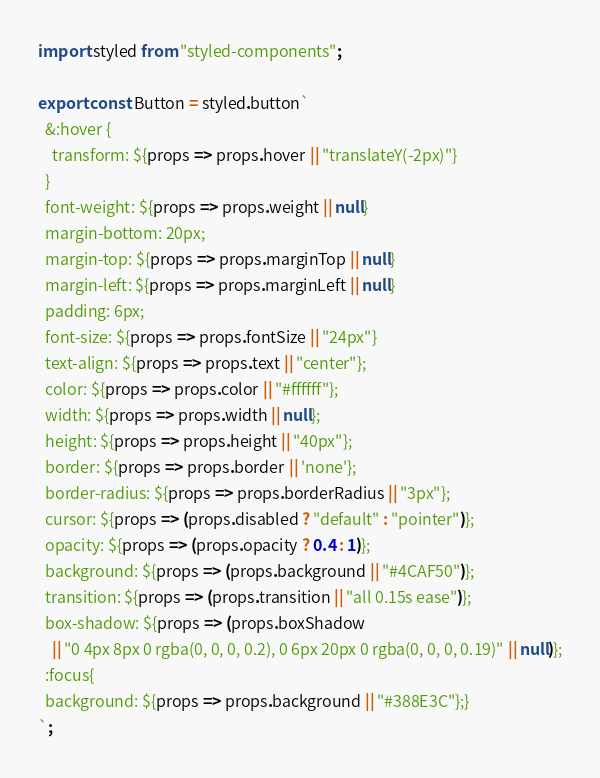<code> <loc_0><loc_0><loc_500><loc_500><_JavaScript_>import styled from "styled-components";

export const Button = styled.button`
  &:hover {
    transform: ${props => props.hover || "translateY(-2px)"}
  }
  font-weight: ${props => props.weight || null}
  margin-bottom: 20px;
  margin-top: ${props => props.marginTop || null}
  margin-left: ${props => props.marginLeft || null}
  padding: 6px;
  font-size: ${props => props.fontSize || "24px"}
  text-align: ${props => props.text || "center"};
  color: ${props => props.color || "#ffffff"};
  width: ${props => props.width || null};
  height: ${props => props.height || "40px"};
  border: ${props => props.border || 'none'};
  border-radius: ${props => props.borderRadius || "3px"};
  cursor: ${props => (props.disabled ? "default" : "pointer")};
  opacity: ${props => (props.opacity ? 0.4 : 1)};
  background: ${props => (props.background || "#4CAF50")};
  transition: ${props => (props.transition || "all 0.15s ease")};
  box-shadow: ${props => (props.boxShadow 
    || "0 4px 8px 0 rgba(0, 0, 0, 0.2), 0 6px 20px 0 rgba(0, 0, 0, 0.19)" || null)};
  :focus{
  background: ${props => props.background || "#388E3C"};}
`;

</code> 